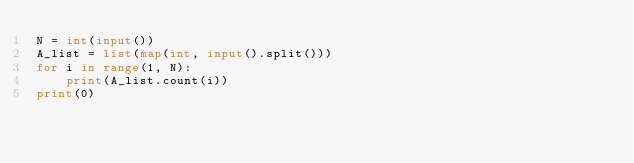<code> <loc_0><loc_0><loc_500><loc_500><_Python_>N = int(input())
A_list = list(map(int, input().split()))
for i in range(1, N):
    print(A_list.count(i))
print(0)
</code> 